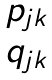Convert formula to latex. <formula><loc_0><loc_0><loc_500><loc_500>\begin{matrix} p _ { j k } \\ q _ { j k } \end{matrix}</formula> 